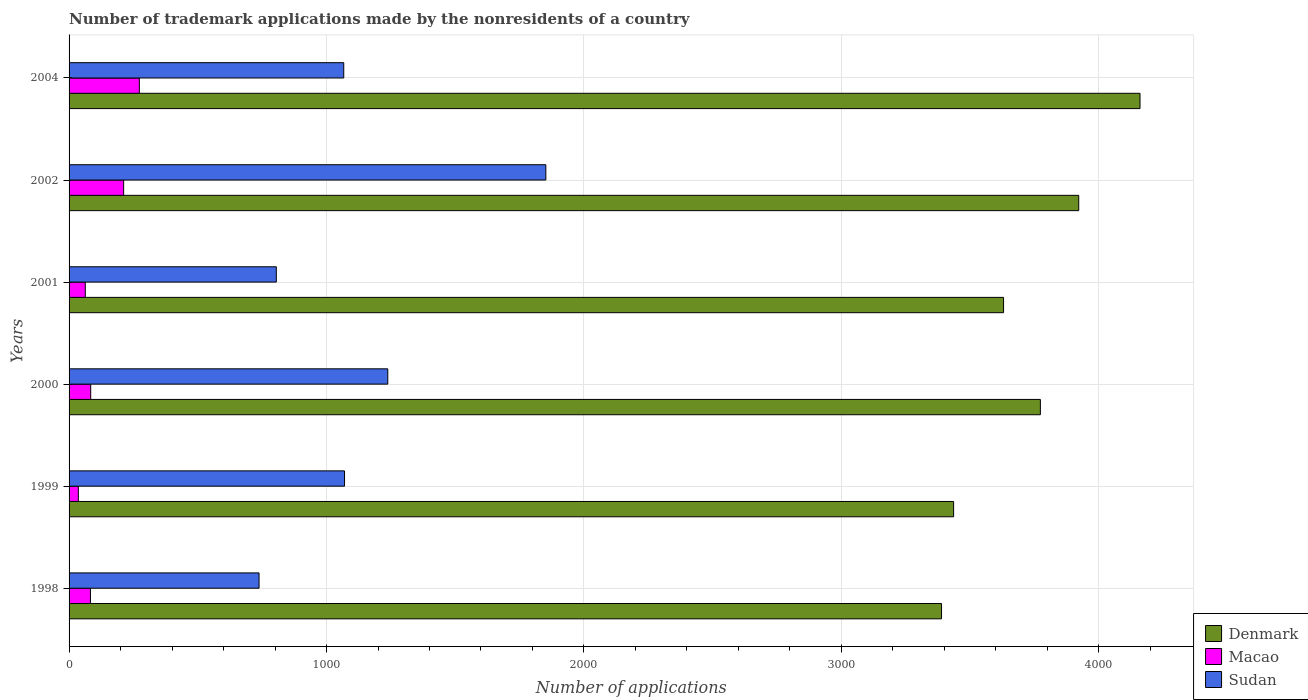How many groups of bars are there?
Your response must be concise. 6. Are the number of bars on each tick of the Y-axis equal?
Your answer should be compact. Yes. How many bars are there on the 2nd tick from the top?
Keep it short and to the point. 3. How many bars are there on the 2nd tick from the bottom?
Your answer should be compact. 3. In how many cases, is the number of bars for a given year not equal to the number of legend labels?
Your answer should be compact. 0. What is the number of trademark applications made by the nonresidents in Sudan in 1999?
Keep it short and to the point. 1070. Across all years, what is the maximum number of trademark applications made by the nonresidents in Macao?
Your response must be concise. 273. Across all years, what is the minimum number of trademark applications made by the nonresidents in Macao?
Your response must be concise. 36. What is the total number of trademark applications made by the nonresidents in Sudan in the graph?
Keep it short and to the point. 6770. What is the difference between the number of trademark applications made by the nonresidents in Macao in 2001 and that in 2004?
Give a very brief answer. -210. What is the difference between the number of trademark applications made by the nonresidents in Macao in 1998 and the number of trademark applications made by the nonresidents in Sudan in 2002?
Keep it short and to the point. -1769. What is the average number of trademark applications made by the nonresidents in Denmark per year?
Keep it short and to the point. 3718.33. In the year 1998, what is the difference between the number of trademark applications made by the nonresidents in Denmark and number of trademark applications made by the nonresidents in Macao?
Ensure brevity in your answer.  3306. In how many years, is the number of trademark applications made by the nonresidents in Macao greater than 800 ?
Offer a very short reply. 0. What is the ratio of the number of trademark applications made by the nonresidents in Macao in 1999 to that in 2004?
Give a very brief answer. 0.13. Is the difference between the number of trademark applications made by the nonresidents in Denmark in 1998 and 2000 greater than the difference between the number of trademark applications made by the nonresidents in Macao in 1998 and 2000?
Your response must be concise. No. What is the difference between the highest and the lowest number of trademark applications made by the nonresidents in Denmark?
Provide a short and direct response. 771. In how many years, is the number of trademark applications made by the nonresidents in Sudan greater than the average number of trademark applications made by the nonresidents in Sudan taken over all years?
Make the answer very short. 2. Is the sum of the number of trademark applications made by the nonresidents in Sudan in 1999 and 2000 greater than the maximum number of trademark applications made by the nonresidents in Macao across all years?
Ensure brevity in your answer.  Yes. What does the 3rd bar from the bottom in 1998 represents?
Keep it short and to the point. Sudan. Is it the case that in every year, the sum of the number of trademark applications made by the nonresidents in Macao and number of trademark applications made by the nonresidents in Denmark is greater than the number of trademark applications made by the nonresidents in Sudan?
Provide a succinct answer. Yes. Are all the bars in the graph horizontal?
Keep it short and to the point. Yes. How many years are there in the graph?
Offer a terse response. 6. Does the graph contain any zero values?
Your answer should be very brief. No. How are the legend labels stacked?
Your response must be concise. Vertical. What is the title of the graph?
Offer a very short reply. Number of trademark applications made by the nonresidents of a country. What is the label or title of the X-axis?
Offer a terse response. Number of applications. What is the Number of applications of Denmark in 1998?
Offer a very short reply. 3389. What is the Number of applications in Macao in 1998?
Provide a short and direct response. 83. What is the Number of applications of Sudan in 1998?
Offer a terse response. 738. What is the Number of applications in Denmark in 1999?
Provide a short and direct response. 3436. What is the Number of applications in Macao in 1999?
Your response must be concise. 36. What is the Number of applications of Sudan in 1999?
Offer a very short reply. 1070. What is the Number of applications in Denmark in 2000?
Give a very brief answer. 3773. What is the Number of applications of Macao in 2000?
Keep it short and to the point. 84. What is the Number of applications in Sudan in 2000?
Offer a very short reply. 1238. What is the Number of applications of Denmark in 2001?
Offer a terse response. 3630. What is the Number of applications in Macao in 2001?
Your answer should be compact. 63. What is the Number of applications in Sudan in 2001?
Provide a succinct answer. 805. What is the Number of applications of Denmark in 2002?
Provide a short and direct response. 3922. What is the Number of applications in Macao in 2002?
Your answer should be compact. 212. What is the Number of applications of Sudan in 2002?
Offer a very short reply. 1852. What is the Number of applications in Denmark in 2004?
Your response must be concise. 4160. What is the Number of applications in Macao in 2004?
Offer a very short reply. 273. What is the Number of applications in Sudan in 2004?
Provide a succinct answer. 1067. Across all years, what is the maximum Number of applications in Denmark?
Make the answer very short. 4160. Across all years, what is the maximum Number of applications in Macao?
Provide a succinct answer. 273. Across all years, what is the maximum Number of applications of Sudan?
Your answer should be compact. 1852. Across all years, what is the minimum Number of applications of Denmark?
Your answer should be very brief. 3389. Across all years, what is the minimum Number of applications in Sudan?
Your answer should be very brief. 738. What is the total Number of applications of Denmark in the graph?
Keep it short and to the point. 2.23e+04. What is the total Number of applications of Macao in the graph?
Offer a very short reply. 751. What is the total Number of applications in Sudan in the graph?
Ensure brevity in your answer.  6770. What is the difference between the Number of applications of Denmark in 1998 and that in 1999?
Keep it short and to the point. -47. What is the difference between the Number of applications of Macao in 1998 and that in 1999?
Make the answer very short. 47. What is the difference between the Number of applications in Sudan in 1998 and that in 1999?
Your answer should be very brief. -332. What is the difference between the Number of applications in Denmark in 1998 and that in 2000?
Provide a succinct answer. -384. What is the difference between the Number of applications of Macao in 1998 and that in 2000?
Give a very brief answer. -1. What is the difference between the Number of applications in Sudan in 1998 and that in 2000?
Provide a short and direct response. -500. What is the difference between the Number of applications of Denmark in 1998 and that in 2001?
Ensure brevity in your answer.  -241. What is the difference between the Number of applications in Macao in 1998 and that in 2001?
Your response must be concise. 20. What is the difference between the Number of applications in Sudan in 1998 and that in 2001?
Your answer should be very brief. -67. What is the difference between the Number of applications of Denmark in 1998 and that in 2002?
Ensure brevity in your answer.  -533. What is the difference between the Number of applications in Macao in 1998 and that in 2002?
Offer a very short reply. -129. What is the difference between the Number of applications in Sudan in 1998 and that in 2002?
Keep it short and to the point. -1114. What is the difference between the Number of applications of Denmark in 1998 and that in 2004?
Keep it short and to the point. -771. What is the difference between the Number of applications in Macao in 1998 and that in 2004?
Your response must be concise. -190. What is the difference between the Number of applications in Sudan in 1998 and that in 2004?
Your answer should be very brief. -329. What is the difference between the Number of applications of Denmark in 1999 and that in 2000?
Your answer should be compact. -337. What is the difference between the Number of applications in Macao in 1999 and that in 2000?
Your answer should be compact. -48. What is the difference between the Number of applications in Sudan in 1999 and that in 2000?
Your response must be concise. -168. What is the difference between the Number of applications in Denmark in 1999 and that in 2001?
Ensure brevity in your answer.  -194. What is the difference between the Number of applications of Sudan in 1999 and that in 2001?
Give a very brief answer. 265. What is the difference between the Number of applications of Denmark in 1999 and that in 2002?
Your answer should be compact. -486. What is the difference between the Number of applications of Macao in 1999 and that in 2002?
Ensure brevity in your answer.  -176. What is the difference between the Number of applications in Sudan in 1999 and that in 2002?
Make the answer very short. -782. What is the difference between the Number of applications in Denmark in 1999 and that in 2004?
Make the answer very short. -724. What is the difference between the Number of applications of Macao in 1999 and that in 2004?
Offer a terse response. -237. What is the difference between the Number of applications in Sudan in 1999 and that in 2004?
Offer a very short reply. 3. What is the difference between the Number of applications of Denmark in 2000 and that in 2001?
Keep it short and to the point. 143. What is the difference between the Number of applications in Sudan in 2000 and that in 2001?
Your response must be concise. 433. What is the difference between the Number of applications in Denmark in 2000 and that in 2002?
Your response must be concise. -149. What is the difference between the Number of applications in Macao in 2000 and that in 2002?
Keep it short and to the point. -128. What is the difference between the Number of applications of Sudan in 2000 and that in 2002?
Ensure brevity in your answer.  -614. What is the difference between the Number of applications in Denmark in 2000 and that in 2004?
Offer a very short reply. -387. What is the difference between the Number of applications of Macao in 2000 and that in 2004?
Offer a very short reply. -189. What is the difference between the Number of applications in Sudan in 2000 and that in 2004?
Offer a very short reply. 171. What is the difference between the Number of applications in Denmark in 2001 and that in 2002?
Your answer should be compact. -292. What is the difference between the Number of applications in Macao in 2001 and that in 2002?
Offer a terse response. -149. What is the difference between the Number of applications of Sudan in 2001 and that in 2002?
Your answer should be very brief. -1047. What is the difference between the Number of applications of Denmark in 2001 and that in 2004?
Your answer should be very brief. -530. What is the difference between the Number of applications of Macao in 2001 and that in 2004?
Offer a very short reply. -210. What is the difference between the Number of applications of Sudan in 2001 and that in 2004?
Provide a short and direct response. -262. What is the difference between the Number of applications in Denmark in 2002 and that in 2004?
Make the answer very short. -238. What is the difference between the Number of applications in Macao in 2002 and that in 2004?
Your response must be concise. -61. What is the difference between the Number of applications in Sudan in 2002 and that in 2004?
Make the answer very short. 785. What is the difference between the Number of applications of Denmark in 1998 and the Number of applications of Macao in 1999?
Give a very brief answer. 3353. What is the difference between the Number of applications of Denmark in 1998 and the Number of applications of Sudan in 1999?
Your response must be concise. 2319. What is the difference between the Number of applications of Macao in 1998 and the Number of applications of Sudan in 1999?
Keep it short and to the point. -987. What is the difference between the Number of applications in Denmark in 1998 and the Number of applications in Macao in 2000?
Provide a succinct answer. 3305. What is the difference between the Number of applications of Denmark in 1998 and the Number of applications of Sudan in 2000?
Provide a succinct answer. 2151. What is the difference between the Number of applications of Macao in 1998 and the Number of applications of Sudan in 2000?
Offer a very short reply. -1155. What is the difference between the Number of applications of Denmark in 1998 and the Number of applications of Macao in 2001?
Keep it short and to the point. 3326. What is the difference between the Number of applications in Denmark in 1998 and the Number of applications in Sudan in 2001?
Keep it short and to the point. 2584. What is the difference between the Number of applications of Macao in 1998 and the Number of applications of Sudan in 2001?
Offer a very short reply. -722. What is the difference between the Number of applications in Denmark in 1998 and the Number of applications in Macao in 2002?
Your answer should be very brief. 3177. What is the difference between the Number of applications in Denmark in 1998 and the Number of applications in Sudan in 2002?
Your answer should be compact. 1537. What is the difference between the Number of applications of Macao in 1998 and the Number of applications of Sudan in 2002?
Provide a short and direct response. -1769. What is the difference between the Number of applications of Denmark in 1998 and the Number of applications of Macao in 2004?
Your response must be concise. 3116. What is the difference between the Number of applications of Denmark in 1998 and the Number of applications of Sudan in 2004?
Offer a very short reply. 2322. What is the difference between the Number of applications in Macao in 1998 and the Number of applications in Sudan in 2004?
Ensure brevity in your answer.  -984. What is the difference between the Number of applications of Denmark in 1999 and the Number of applications of Macao in 2000?
Provide a short and direct response. 3352. What is the difference between the Number of applications in Denmark in 1999 and the Number of applications in Sudan in 2000?
Provide a succinct answer. 2198. What is the difference between the Number of applications in Macao in 1999 and the Number of applications in Sudan in 2000?
Give a very brief answer. -1202. What is the difference between the Number of applications in Denmark in 1999 and the Number of applications in Macao in 2001?
Your response must be concise. 3373. What is the difference between the Number of applications of Denmark in 1999 and the Number of applications of Sudan in 2001?
Your answer should be very brief. 2631. What is the difference between the Number of applications in Macao in 1999 and the Number of applications in Sudan in 2001?
Offer a very short reply. -769. What is the difference between the Number of applications in Denmark in 1999 and the Number of applications in Macao in 2002?
Offer a very short reply. 3224. What is the difference between the Number of applications of Denmark in 1999 and the Number of applications of Sudan in 2002?
Your response must be concise. 1584. What is the difference between the Number of applications in Macao in 1999 and the Number of applications in Sudan in 2002?
Give a very brief answer. -1816. What is the difference between the Number of applications of Denmark in 1999 and the Number of applications of Macao in 2004?
Provide a succinct answer. 3163. What is the difference between the Number of applications in Denmark in 1999 and the Number of applications in Sudan in 2004?
Make the answer very short. 2369. What is the difference between the Number of applications of Macao in 1999 and the Number of applications of Sudan in 2004?
Ensure brevity in your answer.  -1031. What is the difference between the Number of applications of Denmark in 2000 and the Number of applications of Macao in 2001?
Offer a very short reply. 3710. What is the difference between the Number of applications in Denmark in 2000 and the Number of applications in Sudan in 2001?
Keep it short and to the point. 2968. What is the difference between the Number of applications of Macao in 2000 and the Number of applications of Sudan in 2001?
Keep it short and to the point. -721. What is the difference between the Number of applications in Denmark in 2000 and the Number of applications in Macao in 2002?
Provide a succinct answer. 3561. What is the difference between the Number of applications in Denmark in 2000 and the Number of applications in Sudan in 2002?
Provide a succinct answer. 1921. What is the difference between the Number of applications in Macao in 2000 and the Number of applications in Sudan in 2002?
Make the answer very short. -1768. What is the difference between the Number of applications in Denmark in 2000 and the Number of applications in Macao in 2004?
Offer a very short reply. 3500. What is the difference between the Number of applications of Denmark in 2000 and the Number of applications of Sudan in 2004?
Offer a very short reply. 2706. What is the difference between the Number of applications of Macao in 2000 and the Number of applications of Sudan in 2004?
Provide a short and direct response. -983. What is the difference between the Number of applications of Denmark in 2001 and the Number of applications of Macao in 2002?
Provide a succinct answer. 3418. What is the difference between the Number of applications of Denmark in 2001 and the Number of applications of Sudan in 2002?
Keep it short and to the point. 1778. What is the difference between the Number of applications of Macao in 2001 and the Number of applications of Sudan in 2002?
Ensure brevity in your answer.  -1789. What is the difference between the Number of applications in Denmark in 2001 and the Number of applications in Macao in 2004?
Offer a terse response. 3357. What is the difference between the Number of applications in Denmark in 2001 and the Number of applications in Sudan in 2004?
Your answer should be compact. 2563. What is the difference between the Number of applications of Macao in 2001 and the Number of applications of Sudan in 2004?
Provide a short and direct response. -1004. What is the difference between the Number of applications in Denmark in 2002 and the Number of applications in Macao in 2004?
Offer a terse response. 3649. What is the difference between the Number of applications of Denmark in 2002 and the Number of applications of Sudan in 2004?
Give a very brief answer. 2855. What is the difference between the Number of applications in Macao in 2002 and the Number of applications in Sudan in 2004?
Ensure brevity in your answer.  -855. What is the average Number of applications of Denmark per year?
Ensure brevity in your answer.  3718.33. What is the average Number of applications in Macao per year?
Provide a short and direct response. 125.17. What is the average Number of applications of Sudan per year?
Your response must be concise. 1128.33. In the year 1998, what is the difference between the Number of applications of Denmark and Number of applications of Macao?
Your response must be concise. 3306. In the year 1998, what is the difference between the Number of applications of Denmark and Number of applications of Sudan?
Your response must be concise. 2651. In the year 1998, what is the difference between the Number of applications in Macao and Number of applications in Sudan?
Your response must be concise. -655. In the year 1999, what is the difference between the Number of applications in Denmark and Number of applications in Macao?
Your answer should be very brief. 3400. In the year 1999, what is the difference between the Number of applications in Denmark and Number of applications in Sudan?
Provide a succinct answer. 2366. In the year 1999, what is the difference between the Number of applications of Macao and Number of applications of Sudan?
Provide a succinct answer. -1034. In the year 2000, what is the difference between the Number of applications of Denmark and Number of applications of Macao?
Ensure brevity in your answer.  3689. In the year 2000, what is the difference between the Number of applications in Denmark and Number of applications in Sudan?
Offer a very short reply. 2535. In the year 2000, what is the difference between the Number of applications of Macao and Number of applications of Sudan?
Give a very brief answer. -1154. In the year 2001, what is the difference between the Number of applications of Denmark and Number of applications of Macao?
Provide a short and direct response. 3567. In the year 2001, what is the difference between the Number of applications in Denmark and Number of applications in Sudan?
Give a very brief answer. 2825. In the year 2001, what is the difference between the Number of applications in Macao and Number of applications in Sudan?
Make the answer very short. -742. In the year 2002, what is the difference between the Number of applications in Denmark and Number of applications in Macao?
Your answer should be very brief. 3710. In the year 2002, what is the difference between the Number of applications in Denmark and Number of applications in Sudan?
Your answer should be very brief. 2070. In the year 2002, what is the difference between the Number of applications of Macao and Number of applications of Sudan?
Ensure brevity in your answer.  -1640. In the year 2004, what is the difference between the Number of applications in Denmark and Number of applications in Macao?
Your answer should be very brief. 3887. In the year 2004, what is the difference between the Number of applications in Denmark and Number of applications in Sudan?
Ensure brevity in your answer.  3093. In the year 2004, what is the difference between the Number of applications of Macao and Number of applications of Sudan?
Provide a succinct answer. -794. What is the ratio of the Number of applications of Denmark in 1998 to that in 1999?
Ensure brevity in your answer.  0.99. What is the ratio of the Number of applications of Macao in 1998 to that in 1999?
Keep it short and to the point. 2.31. What is the ratio of the Number of applications in Sudan in 1998 to that in 1999?
Your answer should be compact. 0.69. What is the ratio of the Number of applications of Denmark in 1998 to that in 2000?
Your answer should be compact. 0.9. What is the ratio of the Number of applications in Macao in 1998 to that in 2000?
Your answer should be compact. 0.99. What is the ratio of the Number of applications in Sudan in 1998 to that in 2000?
Your answer should be compact. 0.6. What is the ratio of the Number of applications in Denmark in 1998 to that in 2001?
Keep it short and to the point. 0.93. What is the ratio of the Number of applications in Macao in 1998 to that in 2001?
Provide a succinct answer. 1.32. What is the ratio of the Number of applications in Sudan in 1998 to that in 2001?
Make the answer very short. 0.92. What is the ratio of the Number of applications in Denmark in 1998 to that in 2002?
Ensure brevity in your answer.  0.86. What is the ratio of the Number of applications in Macao in 1998 to that in 2002?
Ensure brevity in your answer.  0.39. What is the ratio of the Number of applications of Sudan in 1998 to that in 2002?
Make the answer very short. 0.4. What is the ratio of the Number of applications in Denmark in 1998 to that in 2004?
Your response must be concise. 0.81. What is the ratio of the Number of applications of Macao in 1998 to that in 2004?
Ensure brevity in your answer.  0.3. What is the ratio of the Number of applications of Sudan in 1998 to that in 2004?
Keep it short and to the point. 0.69. What is the ratio of the Number of applications of Denmark in 1999 to that in 2000?
Give a very brief answer. 0.91. What is the ratio of the Number of applications of Macao in 1999 to that in 2000?
Give a very brief answer. 0.43. What is the ratio of the Number of applications in Sudan in 1999 to that in 2000?
Your answer should be compact. 0.86. What is the ratio of the Number of applications of Denmark in 1999 to that in 2001?
Your answer should be very brief. 0.95. What is the ratio of the Number of applications of Sudan in 1999 to that in 2001?
Give a very brief answer. 1.33. What is the ratio of the Number of applications of Denmark in 1999 to that in 2002?
Your answer should be compact. 0.88. What is the ratio of the Number of applications in Macao in 1999 to that in 2002?
Ensure brevity in your answer.  0.17. What is the ratio of the Number of applications in Sudan in 1999 to that in 2002?
Make the answer very short. 0.58. What is the ratio of the Number of applications of Denmark in 1999 to that in 2004?
Ensure brevity in your answer.  0.83. What is the ratio of the Number of applications in Macao in 1999 to that in 2004?
Provide a succinct answer. 0.13. What is the ratio of the Number of applications in Sudan in 1999 to that in 2004?
Keep it short and to the point. 1. What is the ratio of the Number of applications in Denmark in 2000 to that in 2001?
Provide a succinct answer. 1.04. What is the ratio of the Number of applications of Sudan in 2000 to that in 2001?
Ensure brevity in your answer.  1.54. What is the ratio of the Number of applications of Denmark in 2000 to that in 2002?
Your answer should be very brief. 0.96. What is the ratio of the Number of applications of Macao in 2000 to that in 2002?
Your answer should be compact. 0.4. What is the ratio of the Number of applications in Sudan in 2000 to that in 2002?
Your answer should be very brief. 0.67. What is the ratio of the Number of applications of Denmark in 2000 to that in 2004?
Your answer should be compact. 0.91. What is the ratio of the Number of applications in Macao in 2000 to that in 2004?
Give a very brief answer. 0.31. What is the ratio of the Number of applications of Sudan in 2000 to that in 2004?
Offer a very short reply. 1.16. What is the ratio of the Number of applications of Denmark in 2001 to that in 2002?
Ensure brevity in your answer.  0.93. What is the ratio of the Number of applications in Macao in 2001 to that in 2002?
Make the answer very short. 0.3. What is the ratio of the Number of applications in Sudan in 2001 to that in 2002?
Offer a terse response. 0.43. What is the ratio of the Number of applications in Denmark in 2001 to that in 2004?
Offer a terse response. 0.87. What is the ratio of the Number of applications of Macao in 2001 to that in 2004?
Keep it short and to the point. 0.23. What is the ratio of the Number of applications of Sudan in 2001 to that in 2004?
Provide a succinct answer. 0.75. What is the ratio of the Number of applications in Denmark in 2002 to that in 2004?
Offer a very short reply. 0.94. What is the ratio of the Number of applications in Macao in 2002 to that in 2004?
Ensure brevity in your answer.  0.78. What is the ratio of the Number of applications in Sudan in 2002 to that in 2004?
Ensure brevity in your answer.  1.74. What is the difference between the highest and the second highest Number of applications in Denmark?
Your response must be concise. 238. What is the difference between the highest and the second highest Number of applications in Macao?
Keep it short and to the point. 61. What is the difference between the highest and the second highest Number of applications in Sudan?
Offer a terse response. 614. What is the difference between the highest and the lowest Number of applications of Denmark?
Offer a terse response. 771. What is the difference between the highest and the lowest Number of applications in Macao?
Give a very brief answer. 237. What is the difference between the highest and the lowest Number of applications in Sudan?
Give a very brief answer. 1114. 